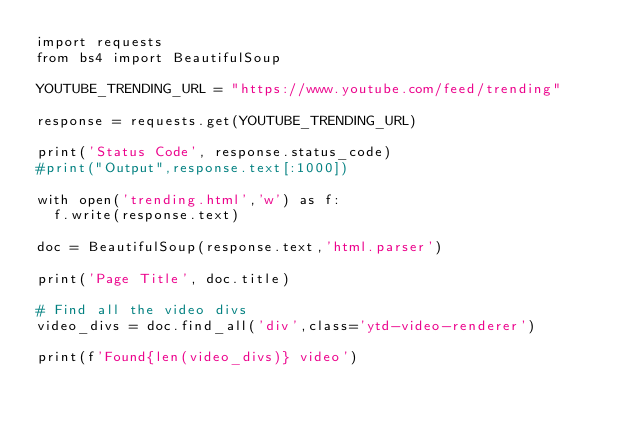Convert code to text. <code><loc_0><loc_0><loc_500><loc_500><_Python_>import requests
from bs4 import BeautifulSoup

YOUTUBE_TRENDING_URL = "https://www.youtube.com/feed/trending"

response = requests.get(YOUTUBE_TRENDING_URL)

print('Status Code', response.status_code)
#print("Output",response.text[:1000])

with open('trending.html','w') as f:
  f.write(response.text)

doc = BeautifulSoup(response.text,'html.parser')

print('Page Title', doc.title)

# Find all the video divs
video_divs = doc.find_all('div',class='ytd-video-renderer')

print(f'Found{len(video_divs)} video')</code> 